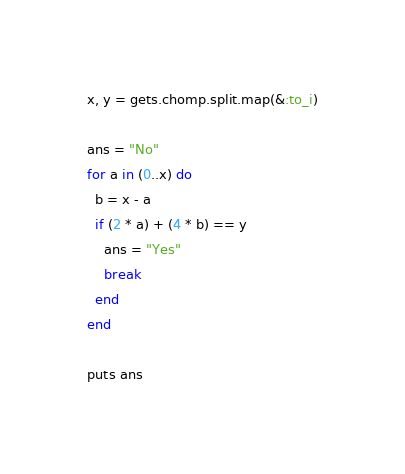<code> <loc_0><loc_0><loc_500><loc_500><_Ruby_>x, y = gets.chomp.split.map(&:to_i)

ans = "No"
for a in (0..x) do
  b = x - a
  if (2 * a) + (4 * b) == y
    ans = "Yes"
    break
  end
end

puts ans
</code> 